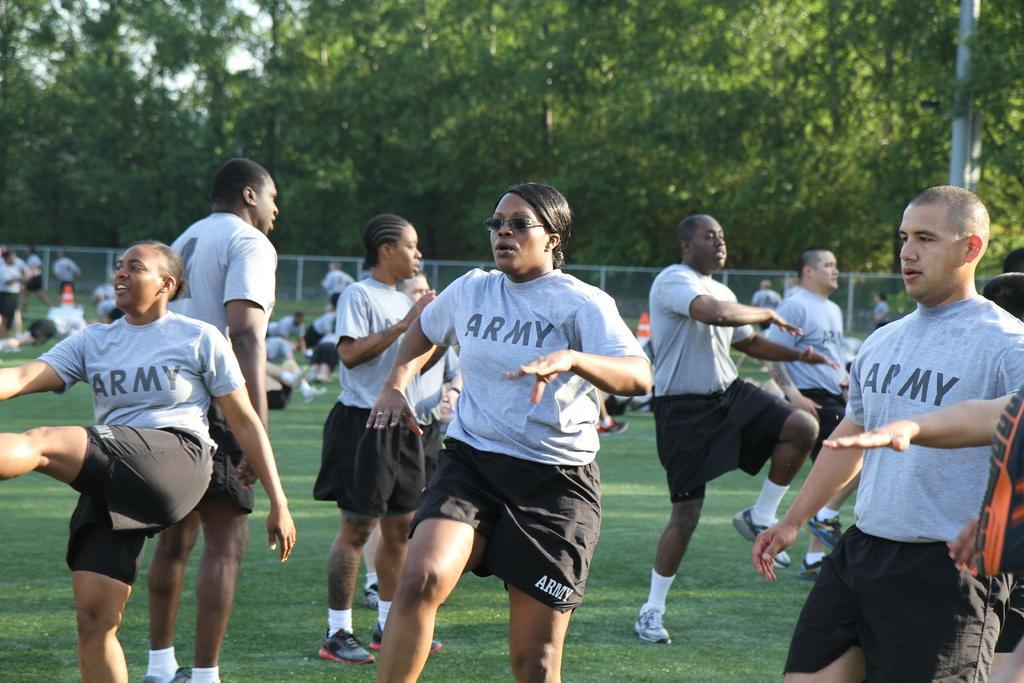Could you give a brief overview of what you see in this image? In this picture we can see a few people on the grass. There is a pole on the right side. We can see some trees in the background. 